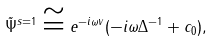<formula> <loc_0><loc_0><loc_500><loc_500>\tilde { \Psi } ^ { s = 1 } \cong e ^ { - i \omega v } ( - i \omega \Delta ^ { - 1 } + c _ { 0 } ) ,</formula> 